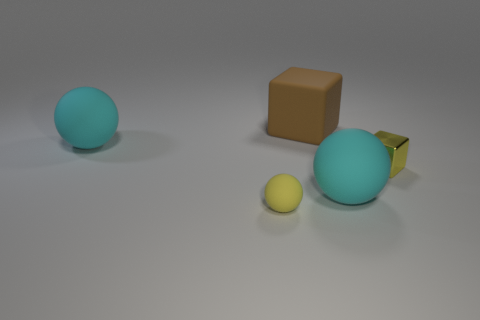There is a rubber ball that is the same color as the small cube; what is its size?
Keep it short and to the point. Small. There is a matte ball that is behind the yellow matte object and in front of the small yellow metal cube; what size is it?
Your answer should be compact. Large. What is the material of the ball that is in front of the big cyan object in front of the cyan sphere that is on the left side of the tiny sphere?
Provide a succinct answer. Rubber. What material is the tiny thing that is the same color as the small ball?
Give a very brief answer. Metal. There is a big rubber ball in front of the metal cube; does it have the same color as the small shiny cube in front of the brown object?
Ensure brevity in your answer.  No. There is a small yellow object left of the cyan rubber sphere to the right of the large object to the left of the yellow matte object; what shape is it?
Your answer should be compact. Sphere. What is the shape of the object that is in front of the metallic object and behind the tiny matte sphere?
Keep it short and to the point. Sphere. What number of yellow blocks are left of the large sphere behind the cyan matte object on the right side of the large brown matte cube?
Your answer should be compact. 0. What is the size of the rubber thing that is the same shape as the metal object?
Keep it short and to the point. Large. Is there anything else that is the same size as the brown rubber cube?
Ensure brevity in your answer.  Yes. 